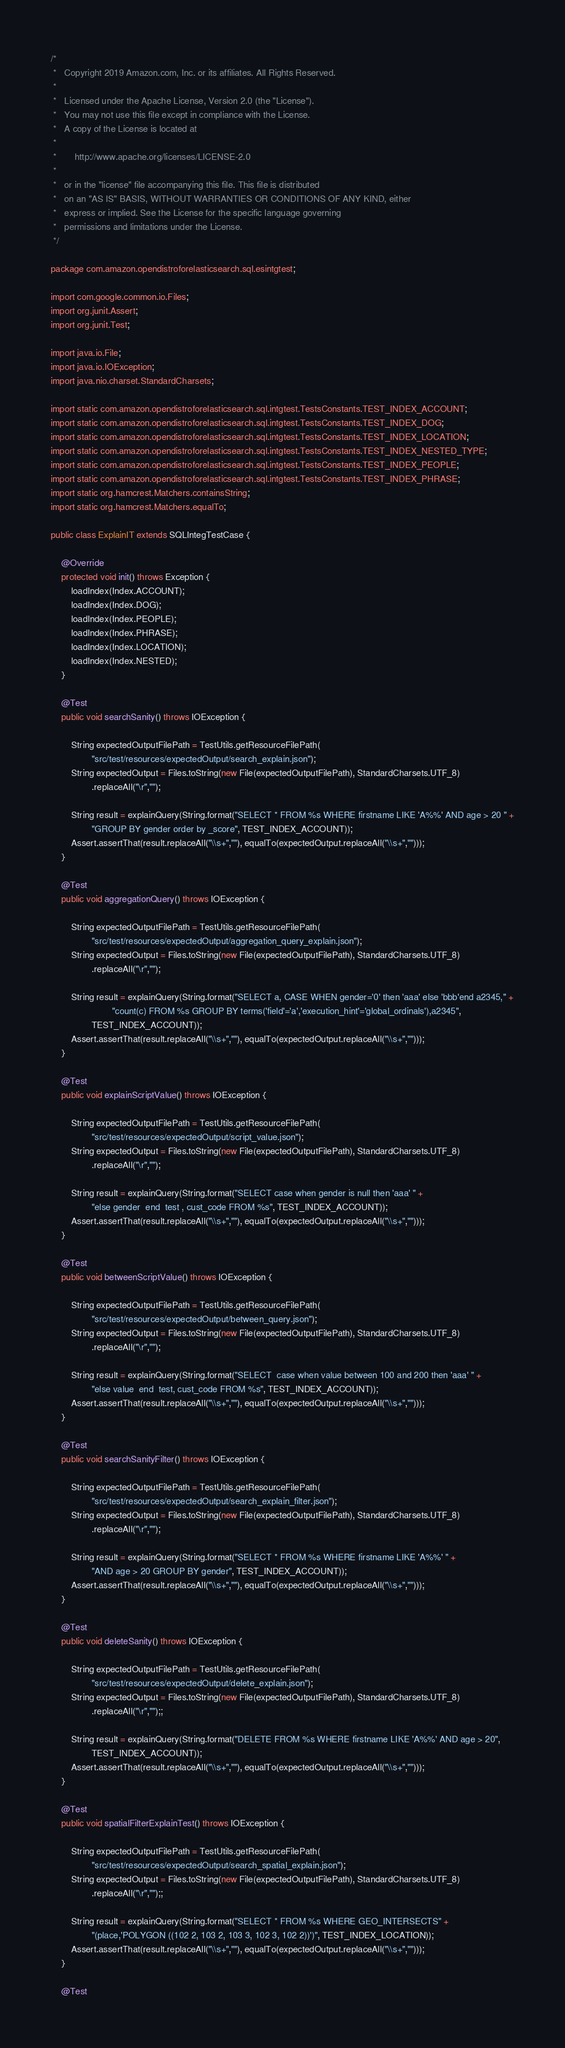<code> <loc_0><loc_0><loc_500><loc_500><_Java_>/*
 *   Copyright 2019 Amazon.com, Inc. or its affiliates. All Rights Reserved.
 *
 *   Licensed under the Apache License, Version 2.0 (the "License").
 *   You may not use this file except in compliance with the License.
 *   A copy of the License is located at
 *
 *       http://www.apache.org/licenses/LICENSE-2.0
 *
 *   or in the "license" file accompanying this file. This file is distributed
 *   on an "AS IS" BASIS, WITHOUT WARRANTIES OR CONDITIONS OF ANY KIND, either
 *   express or implied. See the License for the specific language governing
 *   permissions and limitations under the License.
 */

package com.amazon.opendistroforelasticsearch.sql.esintgtest;

import com.google.common.io.Files;
import org.junit.Assert;
import org.junit.Test;

import java.io.File;
import java.io.IOException;
import java.nio.charset.StandardCharsets;

import static com.amazon.opendistroforelasticsearch.sql.intgtest.TestsConstants.TEST_INDEX_ACCOUNT;
import static com.amazon.opendistroforelasticsearch.sql.intgtest.TestsConstants.TEST_INDEX_DOG;
import static com.amazon.opendistroforelasticsearch.sql.intgtest.TestsConstants.TEST_INDEX_LOCATION;
import static com.amazon.opendistroforelasticsearch.sql.intgtest.TestsConstants.TEST_INDEX_NESTED_TYPE;
import static com.amazon.opendistroforelasticsearch.sql.intgtest.TestsConstants.TEST_INDEX_PEOPLE;
import static com.amazon.opendistroforelasticsearch.sql.intgtest.TestsConstants.TEST_INDEX_PHRASE;
import static org.hamcrest.Matchers.containsString;
import static org.hamcrest.Matchers.equalTo;

public class ExplainIT extends SQLIntegTestCase {

    @Override
    protected void init() throws Exception {
        loadIndex(Index.ACCOUNT);
        loadIndex(Index.DOG);
        loadIndex(Index.PEOPLE);
        loadIndex(Index.PHRASE);
        loadIndex(Index.LOCATION);
        loadIndex(Index.NESTED);
    }

    @Test
    public void searchSanity() throws IOException {

        String expectedOutputFilePath = TestUtils.getResourceFilePath(
                "src/test/resources/expectedOutput/search_explain.json");
        String expectedOutput = Files.toString(new File(expectedOutputFilePath), StandardCharsets.UTF_8)
                .replaceAll("\r","");

        String result = explainQuery(String.format("SELECT * FROM %s WHERE firstname LIKE 'A%%' AND age > 20 " +
                "GROUP BY gender order by _score", TEST_INDEX_ACCOUNT));
        Assert.assertThat(result.replaceAll("\\s+",""), equalTo(expectedOutput.replaceAll("\\s+","")));
    }

    @Test
    public void aggregationQuery() throws IOException {

        String expectedOutputFilePath = TestUtils.getResourceFilePath(
                "src/test/resources/expectedOutput/aggregation_query_explain.json");
        String expectedOutput = Files.toString(new File(expectedOutputFilePath), StandardCharsets.UTF_8)
                .replaceAll("\r","");

        String result = explainQuery(String.format("SELECT a, CASE WHEN gender='0' then 'aaa' else 'bbb'end a2345," +
                        "count(c) FROM %s GROUP BY terms('field'='a','execution_hint'='global_ordinals'),a2345",
                TEST_INDEX_ACCOUNT));
        Assert.assertThat(result.replaceAll("\\s+",""), equalTo(expectedOutput.replaceAll("\\s+","")));
    }

    @Test
    public void explainScriptValue() throws IOException {

        String expectedOutputFilePath = TestUtils.getResourceFilePath(
                "src/test/resources/expectedOutput/script_value.json");
        String expectedOutput = Files.toString(new File(expectedOutputFilePath), StandardCharsets.UTF_8)
                .replaceAll("\r","");

        String result = explainQuery(String.format("SELECT case when gender is null then 'aaa' " +
                "else gender  end  test , cust_code FROM %s", TEST_INDEX_ACCOUNT));
        Assert.assertThat(result.replaceAll("\\s+",""), equalTo(expectedOutput.replaceAll("\\s+","")));
    }

    @Test
    public void betweenScriptValue() throws IOException {

        String expectedOutputFilePath = TestUtils.getResourceFilePath(
                "src/test/resources/expectedOutput/between_query.json");
        String expectedOutput = Files.toString(new File(expectedOutputFilePath), StandardCharsets.UTF_8)
                .replaceAll("\r","");

        String result = explainQuery(String.format("SELECT  case when value between 100 and 200 then 'aaa' " +
                "else value  end  test, cust_code FROM %s", TEST_INDEX_ACCOUNT));
        Assert.assertThat(result.replaceAll("\\s+",""), equalTo(expectedOutput.replaceAll("\\s+","")));
    }

    @Test
    public void searchSanityFilter() throws IOException {

        String expectedOutputFilePath = TestUtils.getResourceFilePath(
                "src/test/resources/expectedOutput/search_explain_filter.json");
        String expectedOutput = Files.toString(new File(expectedOutputFilePath), StandardCharsets.UTF_8)
                .replaceAll("\r","");

        String result = explainQuery(String.format("SELECT * FROM %s WHERE firstname LIKE 'A%%' " +
                "AND age > 20 GROUP BY gender", TEST_INDEX_ACCOUNT));
        Assert.assertThat(result.replaceAll("\\s+",""), equalTo(expectedOutput.replaceAll("\\s+","")));
    }

    @Test
    public void deleteSanity() throws IOException {

        String expectedOutputFilePath = TestUtils.getResourceFilePath(
                "src/test/resources/expectedOutput/delete_explain.json");
        String expectedOutput = Files.toString(new File(expectedOutputFilePath), StandardCharsets.UTF_8)
                .replaceAll("\r","");;

        String result = explainQuery(String.format("DELETE FROM %s WHERE firstname LIKE 'A%%' AND age > 20",
                TEST_INDEX_ACCOUNT));
        Assert.assertThat(result.replaceAll("\\s+",""), equalTo(expectedOutput.replaceAll("\\s+","")));
    }

    @Test
    public void spatialFilterExplainTest() throws IOException {

        String expectedOutputFilePath = TestUtils.getResourceFilePath(
                "src/test/resources/expectedOutput/search_spatial_explain.json");
        String expectedOutput = Files.toString(new File(expectedOutputFilePath), StandardCharsets.UTF_8)
                .replaceAll("\r","");;

        String result = explainQuery(String.format("SELECT * FROM %s WHERE GEO_INTERSECTS" +
                "(place,'POLYGON ((102 2, 103 2, 103 3, 102 3, 102 2))')", TEST_INDEX_LOCATION));
        Assert.assertThat(result.replaceAll("\\s+",""), equalTo(expectedOutput.replaceAll("\\s+","")));
    }

    @Test</code> 